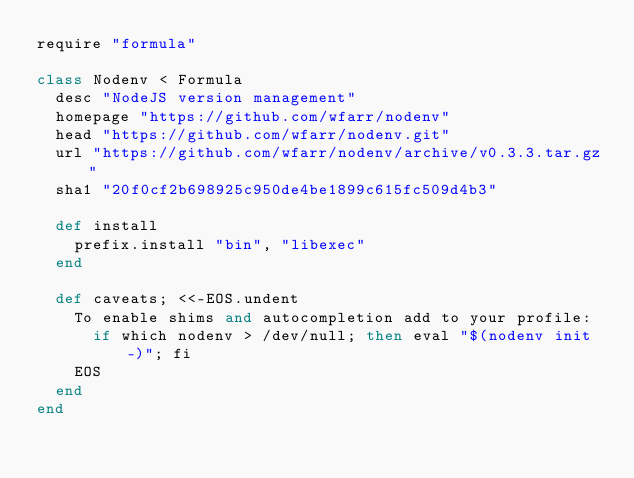<code> <loc_0><loc_0><loc_500><loc_500><_Ruby_>require "formula"

class Nodenv < Formula
  desc "NodeJS version management"
  homepage "https://github.com/wfarr/nodenv"
  head "https://github.com/wfarr/nodenv.git"
  url "https://github.com/wfarr/nodenv/archive/v0.3.3.tar.gz"
  sha1 "20f0cf2b698925c950de4be1899c615fc509d4b3"

  def install
    prefix.install "bin", "libexec"
  end

  def caveats; <<-EOS.undent
    To enable shims and autocompletion add to your profile:
      if which nodenv > /dev/null; then eval "$(nodenv init -)"; fi
    EOS
  end
end
</code> 